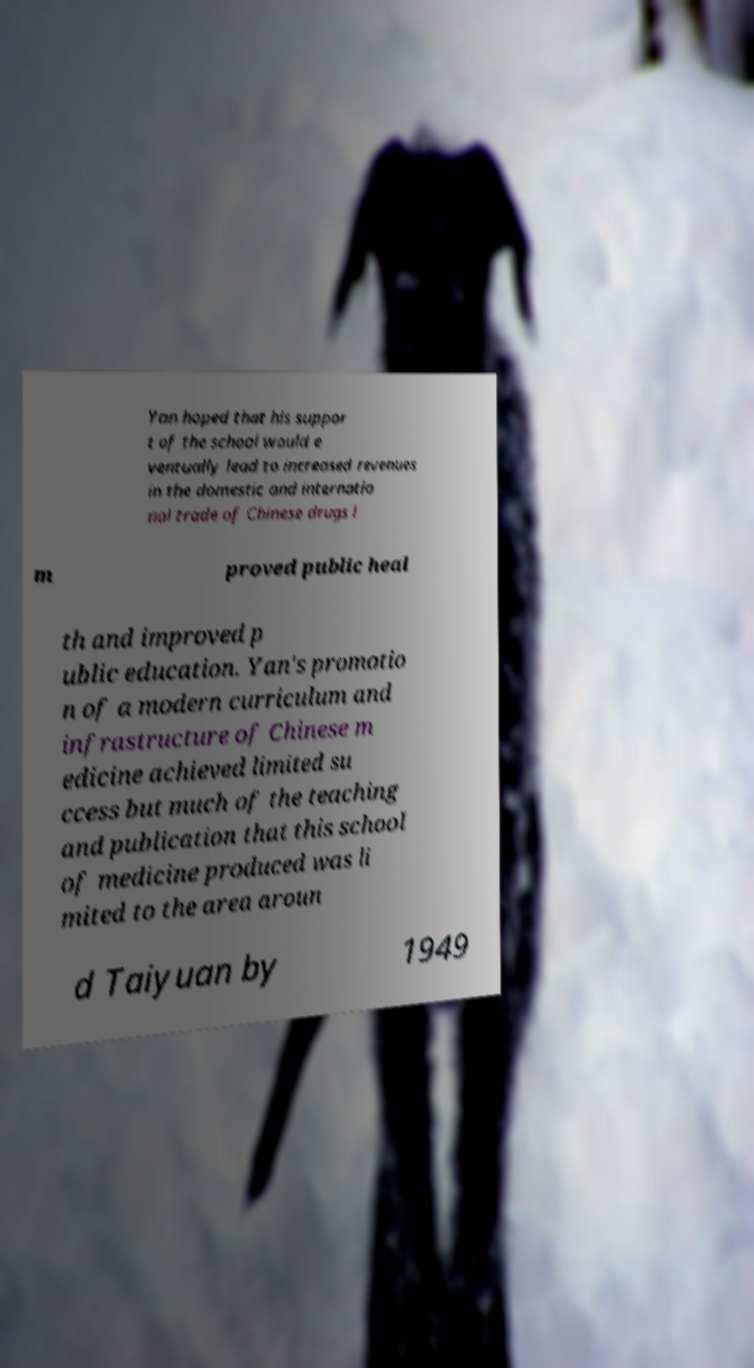I need the written content from this picture converted into text. Can you do that? Yan hoped that his suppor t of the school would e ventually lead to increased revenues in the domestic and internatio nal trade of Chinese drugs i m proved public heal th and improved p ublic education. Yan's promotio n of a modern curriculum and infrastructure of Chinese m edicine achieved limited su ccess but much of the teaching and publication that this school of medicine produced was li mited to the area aroun d Taiyuan by 1949 